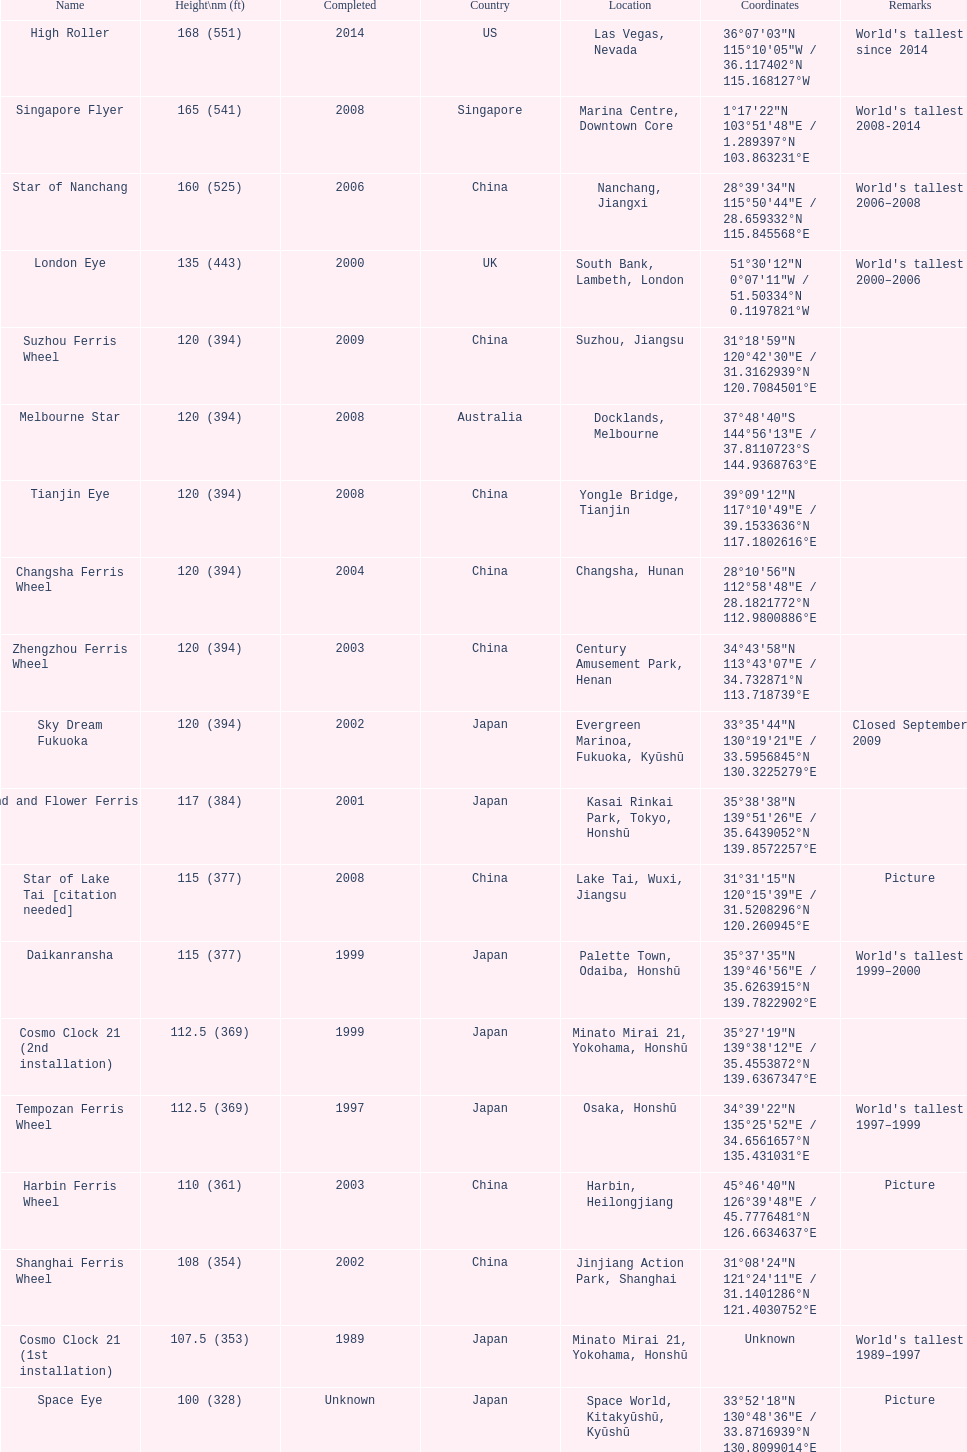Out of star of lake tai, star of nanchang, and melbourne star, which roller coaster was established first? Star of Nanchang. 